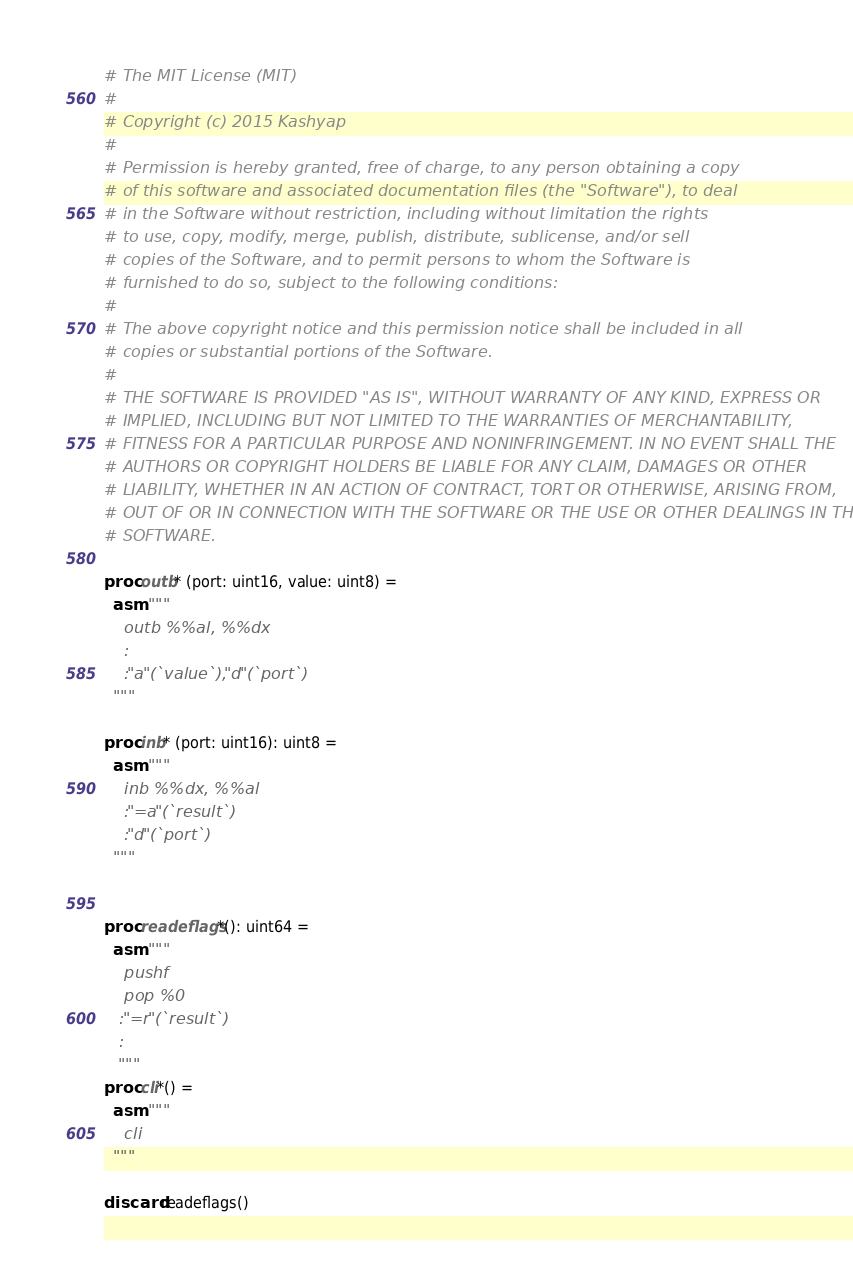Convert code to text. <code><loc_0><loc_0><loc_500><loc_500><_Nim_># The MIT License (MIT)
# 
# Copyright (c) 2015 Kashyap
# 
# Permission is hereby granted, free of charge, to any person obtaining a copy
# of this software and associated documentation files (the "Software"), to deal
# in the Software without restriction, including without limitation the rights
# to use, copy, modify, merge, publish, distribute, sublicense, and/or sell
# copies of the Software, and to permit persons to whom the Software is
# furnished to do so, subject to the following conditions:
# 
# The above copyright notice and this permission notice shall be included in all
# copies or substantial portions of the Software.
# 
# THE SOFTWARE IS PROVIDED "AS IS", WITHOUT WARRANTY OF ANY KIND, EXPRESS OR
# IMPLIED, INCLUDING BUT NOT LIMITED TO THE WARRANTIES OF MERCHANTABILITY,
# FITNESS FOR A PARTICULAR PURPOSE AND NONINFRINGEMENT. IN NO EVENT SHALL THE
# AUTHORS OR COPYRIGHT HOLDERS BE LIABLE FOR ANY CLAIM, DAMAGES OR OTHER
# LIABILITY, WHETHER IN AN ACTION OF CONTRACT, TORT OR OTHERWISE, ARISING FROM,
# OUT OF OR IN CONNECTION WITH THE SOFTWARE OR THE USE OR OTHER DEALINGS IN THE
# SOFTWARE.

proc outb* (port: uint16, value: uint8) =
  asm """
    outb %%al, %%dx
    :
    :"a"(`value`), "d"(`port`)
  """  

proc inb* (port: uint16): uint8 =
  asm """
    inb %%dx, %%al
    :"=a"(`result`)
    :"d"(`port`)
  """


proc readeflags*(): uint64 = 
  asm """
    pushf
    pop %0
   :"=r"(`result`)
   :
   """
proc cli*() =
  asm """
    cli
  """

discard readeflags()
</code> 